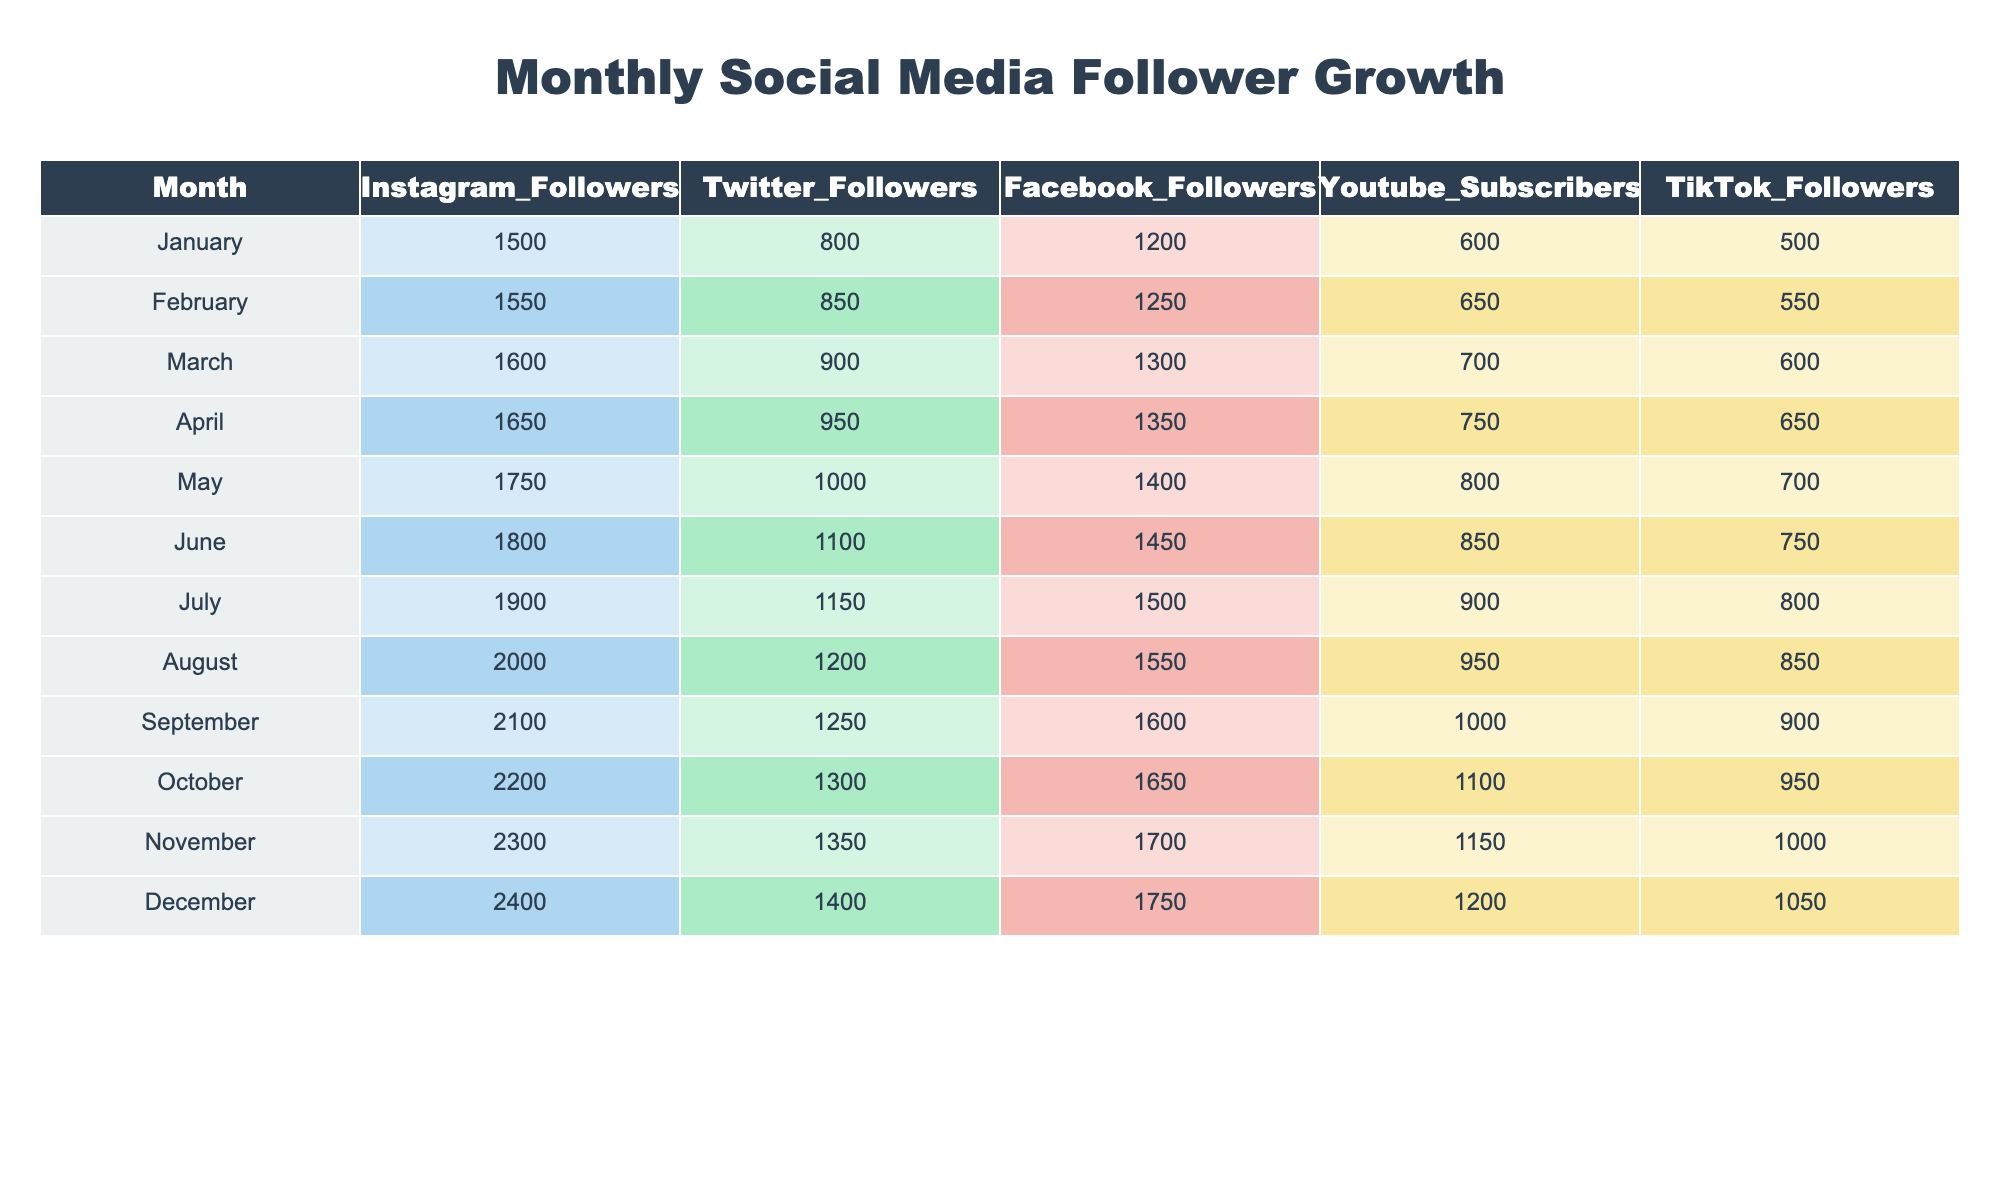What was the follower count for Instagram in February? The table shows that the Instagram follower count in February was 1550.
Answer: 1550 What was the total follower count across all platforms in April? For April, the counts are: Instagram (1650) + Twitter (950) + Facebook (1350) + YouTube (750) + TikTok (650) = 1650 + 950 + 1350 + 750 + 650 = 4350.
Answer: 4350 Did the Twitter followers increase from March to April? In March, the Twitter followers were 900, and in April, they were 950. Since 950 is greater than 900, it confirms an increase.
Answer: Yes What was the average number of Facebook followers from January to December? The Facebook follower counts are: 1200, 1250, 1300, 1350, 1400, 1450, 1500, 1550, 1600, 1650, 1700, 1750. The sum of these counts is 1200 + 1250 + 1300 + 1350 + 1400 + 1450 + 1500 + 1550 + 1600 + 1650 + 1700 + 1750 = 16800. There are 12 months, so the average is 16800 / 12 = 1400.
Answer: 1400 Which month saw the highest growth in TikTok followers? To calculate growth, we look at the difference in follower counts between consecutive months. For instance: January to February (+50); February to March (+50); March to April (+50); through to November to December (+50). Each month saw a growth of 50, making them all equal across the twelve months. Therefore, no single month has the highest growth, as they are all the same.
Answer: None What percentage of total followers in December were from YouTube? The total followers in December across all platforms are: Instagram (2400) + Twitter (1400) + Facebook (1750) + YouTube (1200) + TikTok (1050) = 2400 + 1400 + 1750 + 1200 + 1050 = 8800. The number of YouTube subscribers is 1200. To find the percentage: (1200 / 8800) * 100 = 13.64%.
Answer: 13.64% In which month did the Instagram followers cross 2000? By checking the table, we see that the Instagram followers crossed 2000 in August (2000) for the first time after progressing from previous counts.
Answer: August Is it true that the total Twitter followers exceeded 1300 in November? The total number of Twitter followers in November is 1350, which is indeed greater than 1300. So this statement is true.
Answer: Yes 